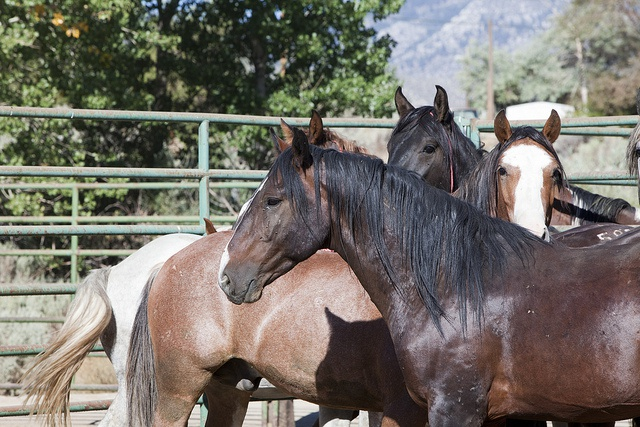Describe the objects in this image and their specific colors. I can see horse in black, gray, maroon, and darkgray tones, horse in black, darkgray, and gray tones, horse in black, gray, white, and darkgray tones, and horse in black, lightgray, darkgray, and tan tones in this image. 